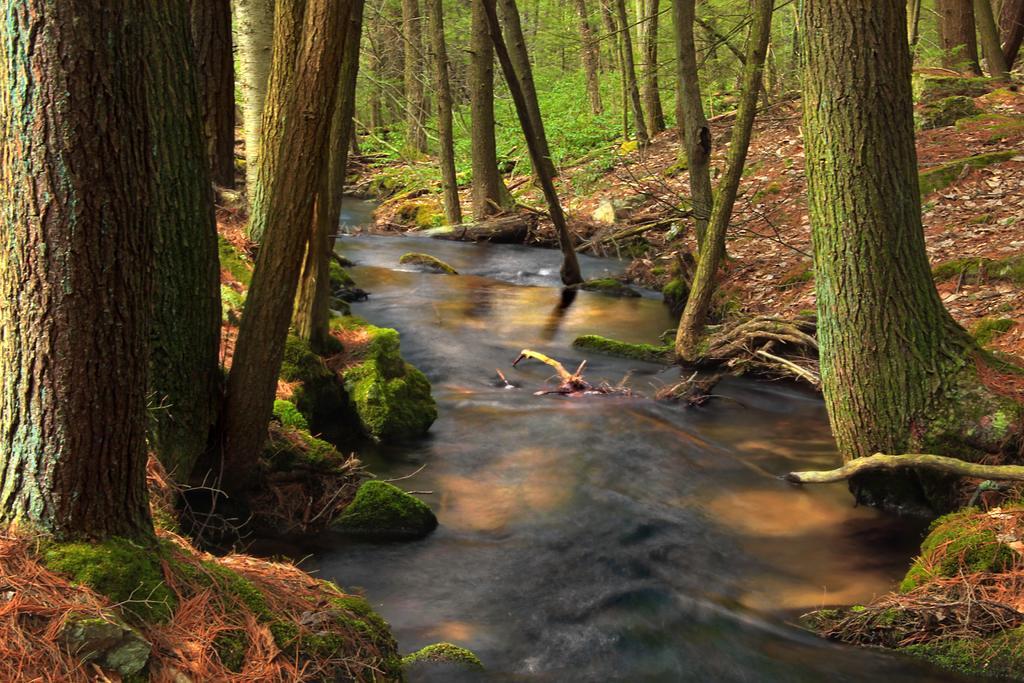Please provide a concise description of this image. In the center of the image water is present. On the left and right side of the image we can see some trees, plants, ground and some dry leaves are present. 